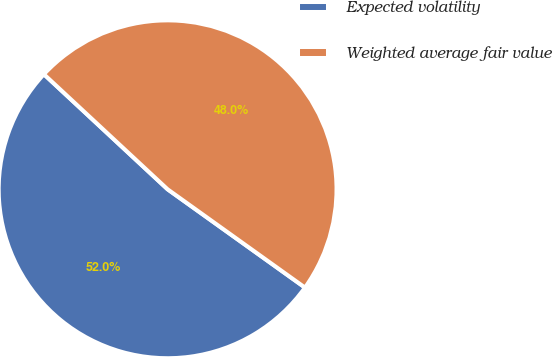<chart> <loc_0><loc_0><loc_500><loc_500><pie_chart><fcel>Expected volatility<fcel>Weighted average fair value<nl><fcel>52.04%<fcel>47.96%<nl></chart> 